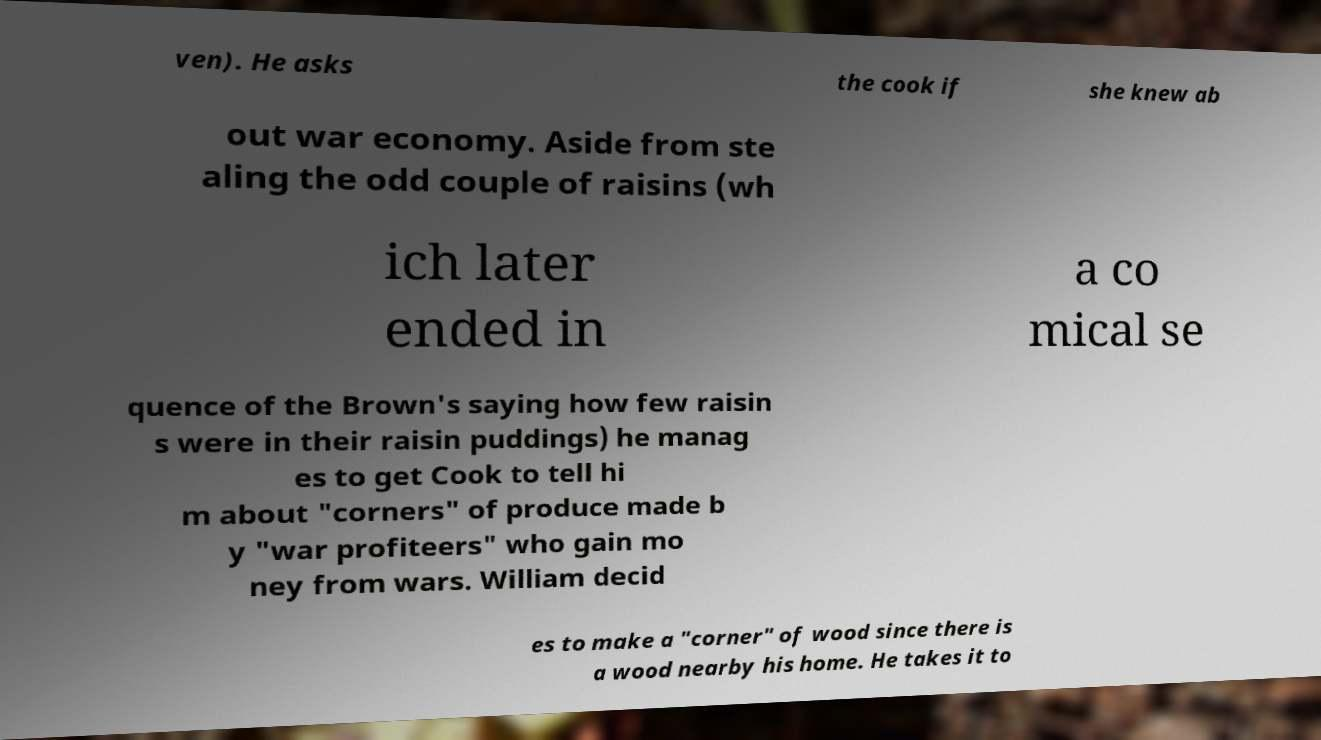I need the written content from this picture converted into text. Can you do that? ven). He asks the cook if she knew ab out war economy. Aside from ste aling the odd couple of raisins (wh ich later ended in a co mical se quence of the Brown's saying how few raisin s were in their raisin puddings) he manag es to get Cook to tell hi m about "corners" of produce made b y "war profiteers" who gain mo ney from wars. William decid es to make a "corner" of wood since there is a wood nearby his home. He takes it to 